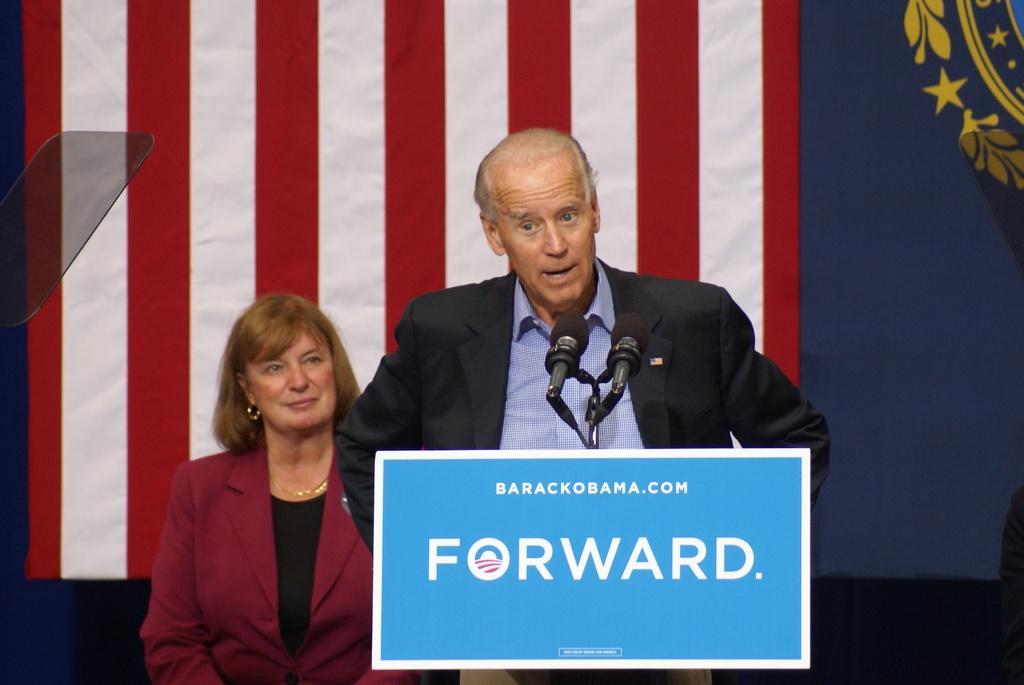Could you give a brief overview of what you see in this image? Here in this picture in the front we can see a person standing over a place and in front of them we can see a speech desk present and on that we can see microphone present and we can see he is speaking into microphone present over there and behind him we can see a woman standing over there and behind them we can see a flag present over there. 